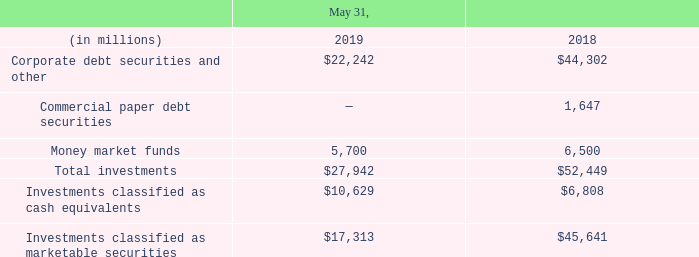3. CASH, CASH EQUIVALENTS AND MARKETABLE SECURITIES
Cash and cash equivalents primarily consist of deposits held at major banks, Tier-1 commercial paper debt securities and other securities with original maturities of 90 days or less. Marketable securities consist of Tier-1 commercial paper debt securities, corporate debt securities and certain other securities.
The amortized principal amounts of our cash, cash equivalents and marketable securities approximated their fair values at May 31, 2019 and 2018. We use the specific identification method to determine any realized gains or losses from the sale of our marketable securities classified as available-for-sale. Such realized gains and losses were insignificant for fiscal 2019, 2018 and 2017. The following table summarizes the components of our cash equivalents and marketable securities held, substantially all of which were classified as available-for-sale:
As of May 31, 2019 and 2018, approximately 33% and 26%, respectively, of our marketable securities investments mature within one year and 67% and 74%, respectively, mature within one to four years. Our investment portfolio is subject to market risk due to changes in interest rates. As described above, we limit purchases of marketable debt securities to investment-grade securities, which have high credit ratings and also limit the amount of credit exposure to any one issuer. As stated in our investment policy, we are averse to principal loss and seek to preserve our invested funds by limiting default risk and market risk.
Restricted cash that was included within cash and cash equivalents as presented within our consolidated balance sheets as of May 31, 2019 and 2018 and our consolidated statements of cash flows for the years ended May 31, 2019, 2018 and 2017 was nominal.
What do cash and cash equivalents primarily consist of? Cash and cash equivalents primarily consist of deposits held at major banks, tier-1 commercial paper debt securities and other securities with original maturities of 90 days or less. Why are purchases of marketable debt securities limited to investment-grade securities? We limit purchases of marketable debt securities to investment-grade securities, which have high credit ratings and also limit the amount of credit exposure to any one issuer. as stated in our investment policy, we are averse to principal loss and seek to preserve our invested funds by limiting default risk and market risk. What was the total investment amount in 2018?
Answer scale should be: million. $52,449. What is the amount of marketable investment securities that will mature within one year by 2020?
Answer scale should be: million. 33%*17,313
Answer: 5713.29. What is the investments classified as cash equivalents as a percentage of the total investments in 2019?
Answer scale should be: percent. (10,629/27,942)
Answer: 38.04. What was the percentage change in the money market funds from 2018 to 2019?
Answer scale should be: percent. (5,700-6,500)/6,500
Answer: -0.12. 